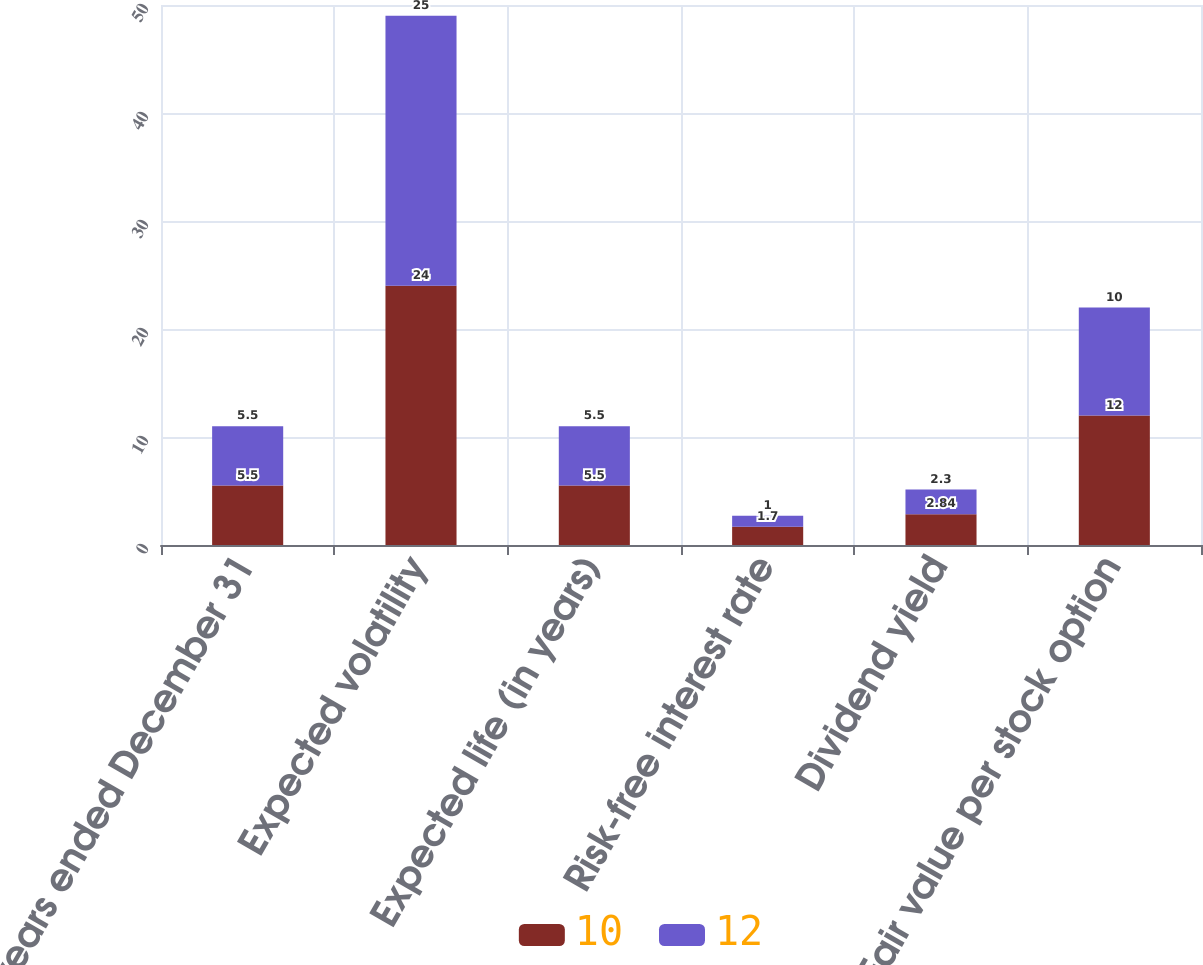Convert chart to OTSL. <chart><loc_0><loc_0><loc_500><loc_500><stacked_bar_chart><ecel><fcel>years ended December 31<fcel>Expected volatility<fcel>Expected life (in years)<fcel>Risk-free interest rate<fcel>Dividend yield<fcel>Fair value per stock option<nl><fcel>10<fcel>5.5<fcel>24<fcel>5.5<fcel>1.7<fcel>2.84<fcel>12<nl><fcel>12<fcel>5.5<fcel>25<fcel>5.5<fcel>1<fcel>2.3<fcel>10<nl></chart> 